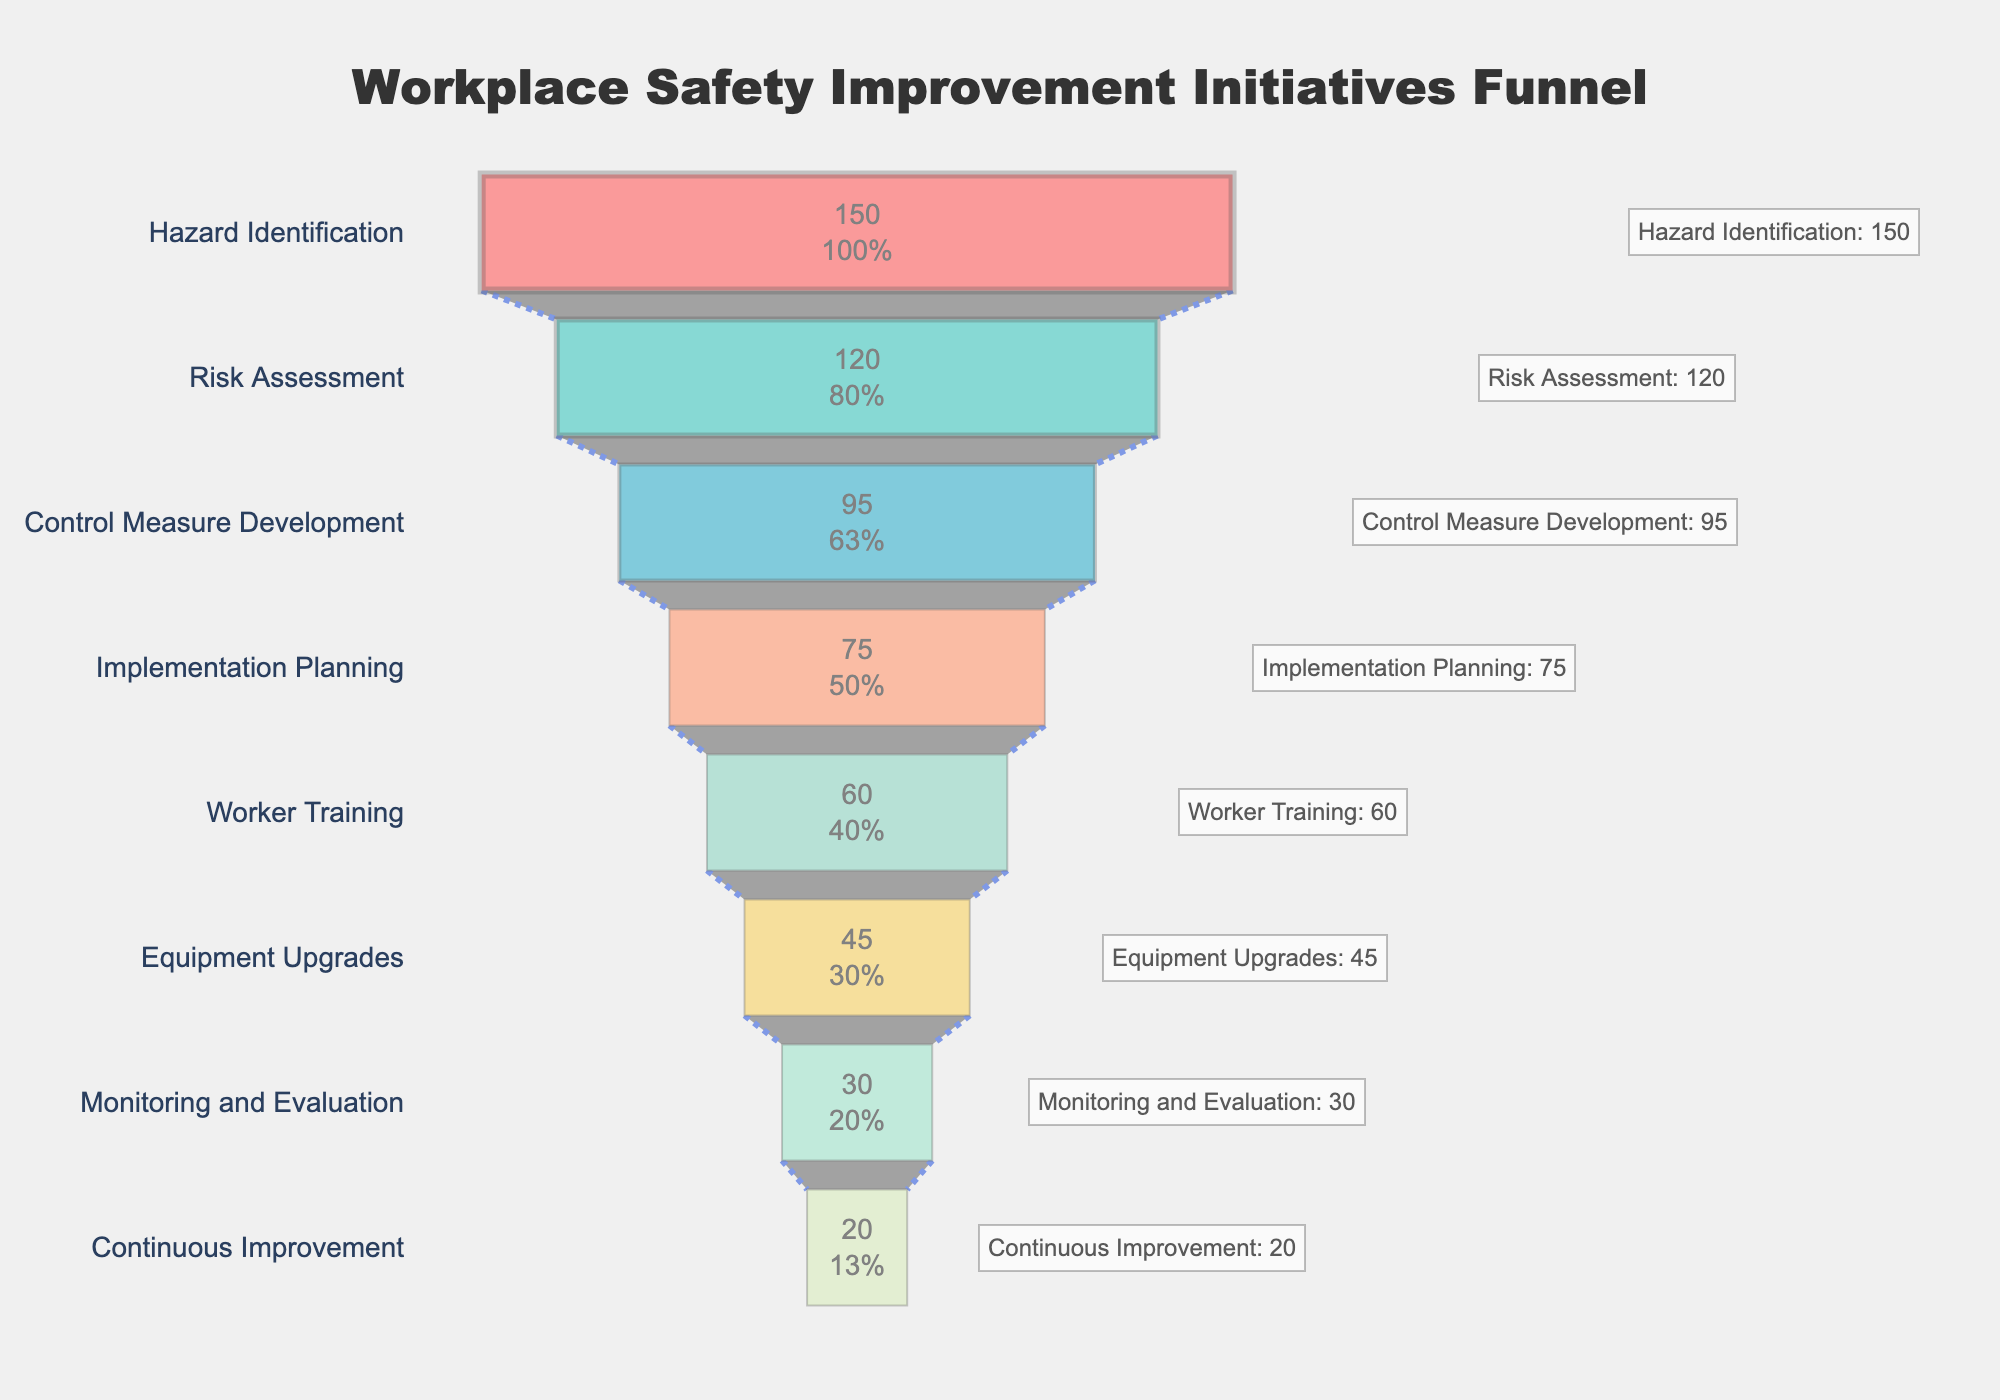What is the title of the chart? The title is positioned at the top of the chart and provides an overview of its content, which is about initiatives to improve workplace safety.
Answer: Workplace Safety Improvement Initiatives Funnel How many steps are there in the funnel chart? The chart shows stages from the initial safety improvements to continuous improvement, listed as different steps. Count each step to find the total number.
Answer: 8 Which step has the lowest number of initiatives? Check the values associated with each step to identify the step with the smallest number. The final step in the funnel will logically have the fewest initiatives due to the funnel shape, representing a reduction in volume at each stage.
Answer: Continuous Improvement What is the difference in the number of initiatives between 'Hazard Identification' and 'Monitoring and Evaluation'? Subtract the number of initiatives in the 'Monitoring and Evaluation' step from those in the 'Hazard Identification' step.
Answer: 150 - 30 = 120 What percentage of the initial initiatives reach the 'Worker Training' stage? The 'Worker Training' stage has 60 initiatives. To find the percentage, divide this number by the initial number of initiatives and multiply by 100.
Answer: (60/150) * 100 = 40% Which step marks the biggest drop in the number of initiatives compared to the previous step? Examine the differences between each consecutive pair of steps, identifying the pair with the largest difference. Subtract the number of initiatives at each step from the previous step and find the maximum difference.
Answer: Hazard Identification to Risk Assessment (150 - 120 = 30) How many initiatives are accounted for by the final three steps in total? Add the number of initiatives for 'Equipment Upgrades', 'Monitoring and Evaluation', and 'Continuous Improvement' to find the total.
Answer: 45 + 30 + 20 = 95 What is the value difference between the 'Control Measure Development' step and the 'Risk Assessment' step? Subtract the number of initiatives in 'Control Measure Development' from those in 'Risk Assessment'.
Answer: 120 - 95 = 25 Which color is associated with the 'Risk Assessment' step? The 'Risk Assessment' step is the second one listed. The corresponding color in the funnel chart appears right next to the first color and typically shows a gradient or contrast.
Answer: Light Blue (Teal) If you combine the initiatives for 'Implementation Planning' and 'Worker Training', what fraction do they represent out of the initiatives in 'Hazard Identification'? Add the initiatives for 'Implementation Planning' and 'Worker Training', then divide by the number of initiatives in 'Hazard Identification'. Simplify the fraction if necessary.
Answer: (75 + 60) / 150 = 135 / 150 = 9 / 10 